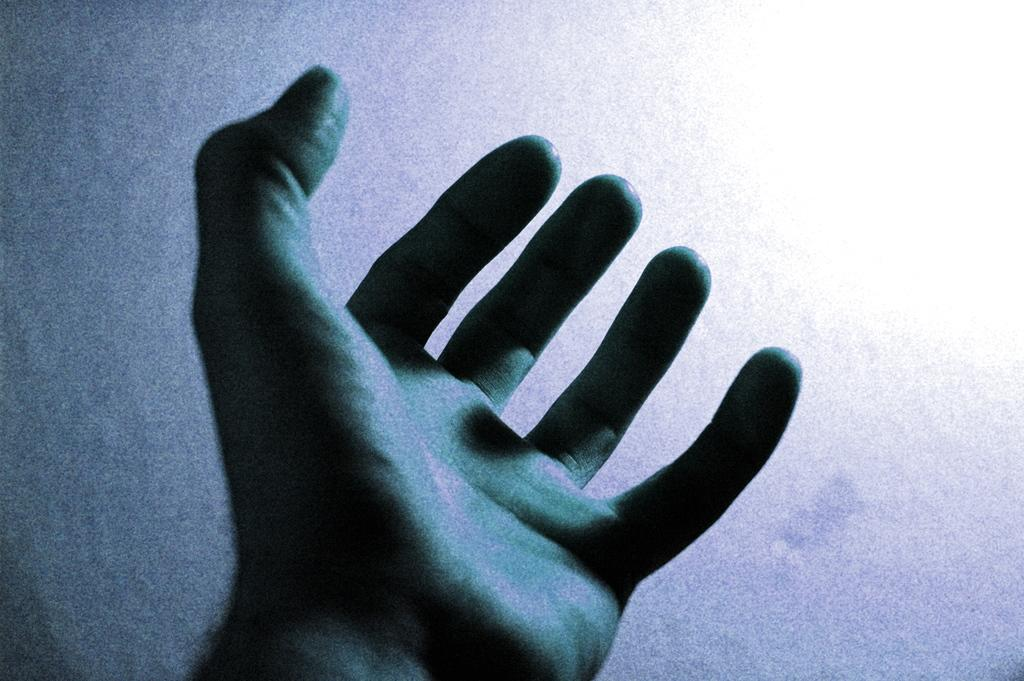What is the main subject of the image? The main subject of the image is the hand of a person. What can be observed about the background of the image? The background appears to be white. What type of leather is being copied in the image? There is no leather or copying activity present in the image; it only features a hand and a white background. 